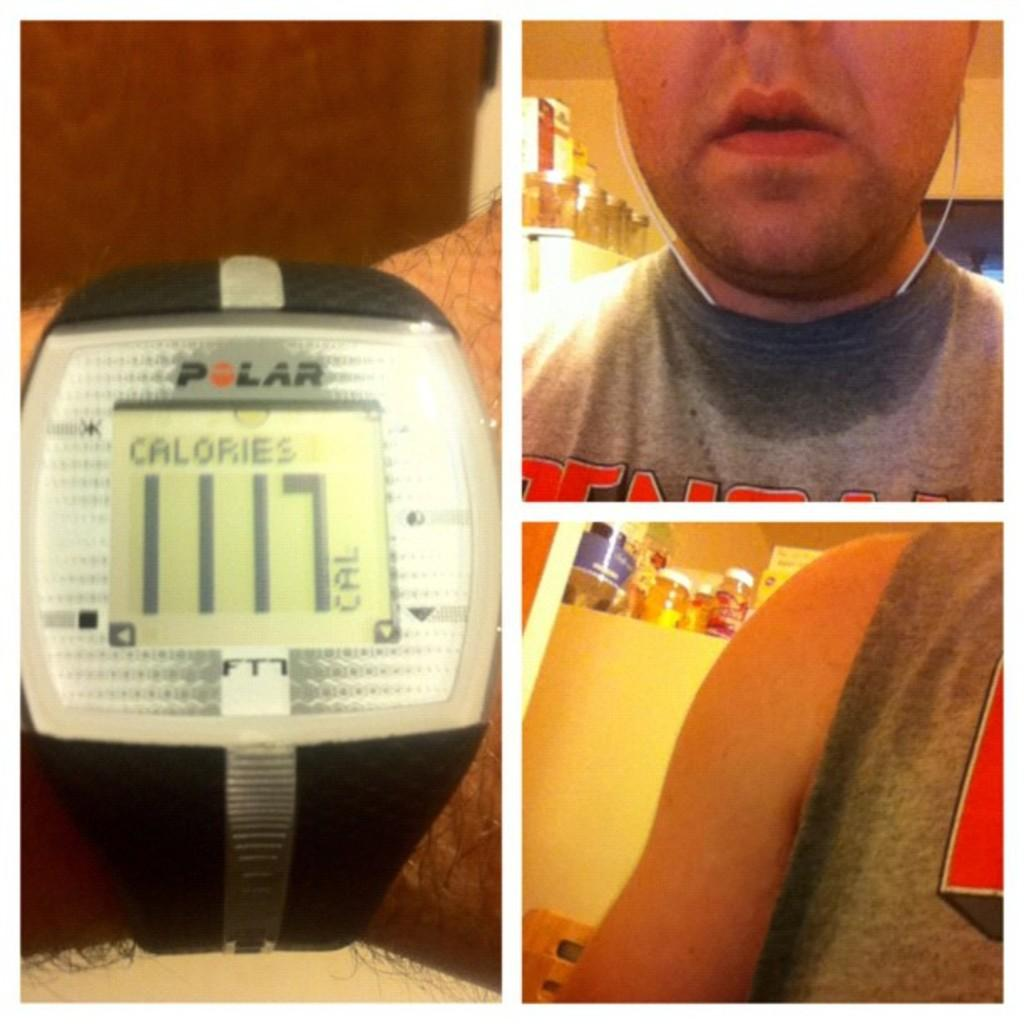<image>
Present a compact description of the photo's key features. A Polar electronic device has a digital display showing 1117 calories. 